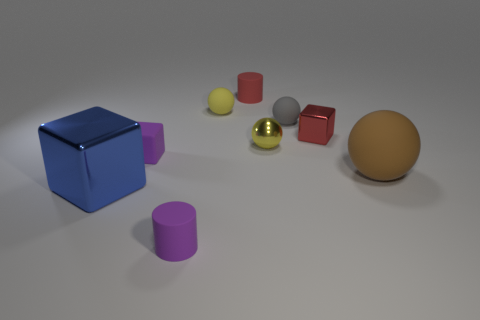Is there another small thing of the same shape as the small red matte thing?
Give a very brief answer. Yes. There is another tiny ball that is the same color as the metal sphere; what material is it?
Make the answer very short. Rubber. How many metal objects are either purple cylinders or cylinders?
Your response must be concise. 0. What shape is the small yellow matte thing?
Your answer should be very brief. Sphere. How many tiny yellow spheres are made of the same material as the large blue object?
Your response must be concise. 1. There is a tiny sphere that is made of the same material as the gray thing; what color is it?
Make the answer very short. Yellow. There is a metallic cube left of the purple cube; is its size the same as the big brown thing?
Offer a very short reply. Yes. The other small metallic object that is the same shape as the blue metal thing is what color?
Offer a very short reply. Red. The purple thing in front of the purple object that is behind the large rubber thing that is on the right side of the tiny red rubber thing is what shape?
Your answer should be compact. Cylinder. Is the shape of the tiny gray rubber object the same as the yellow shiny object?
Your answer should be compact. Yes. 